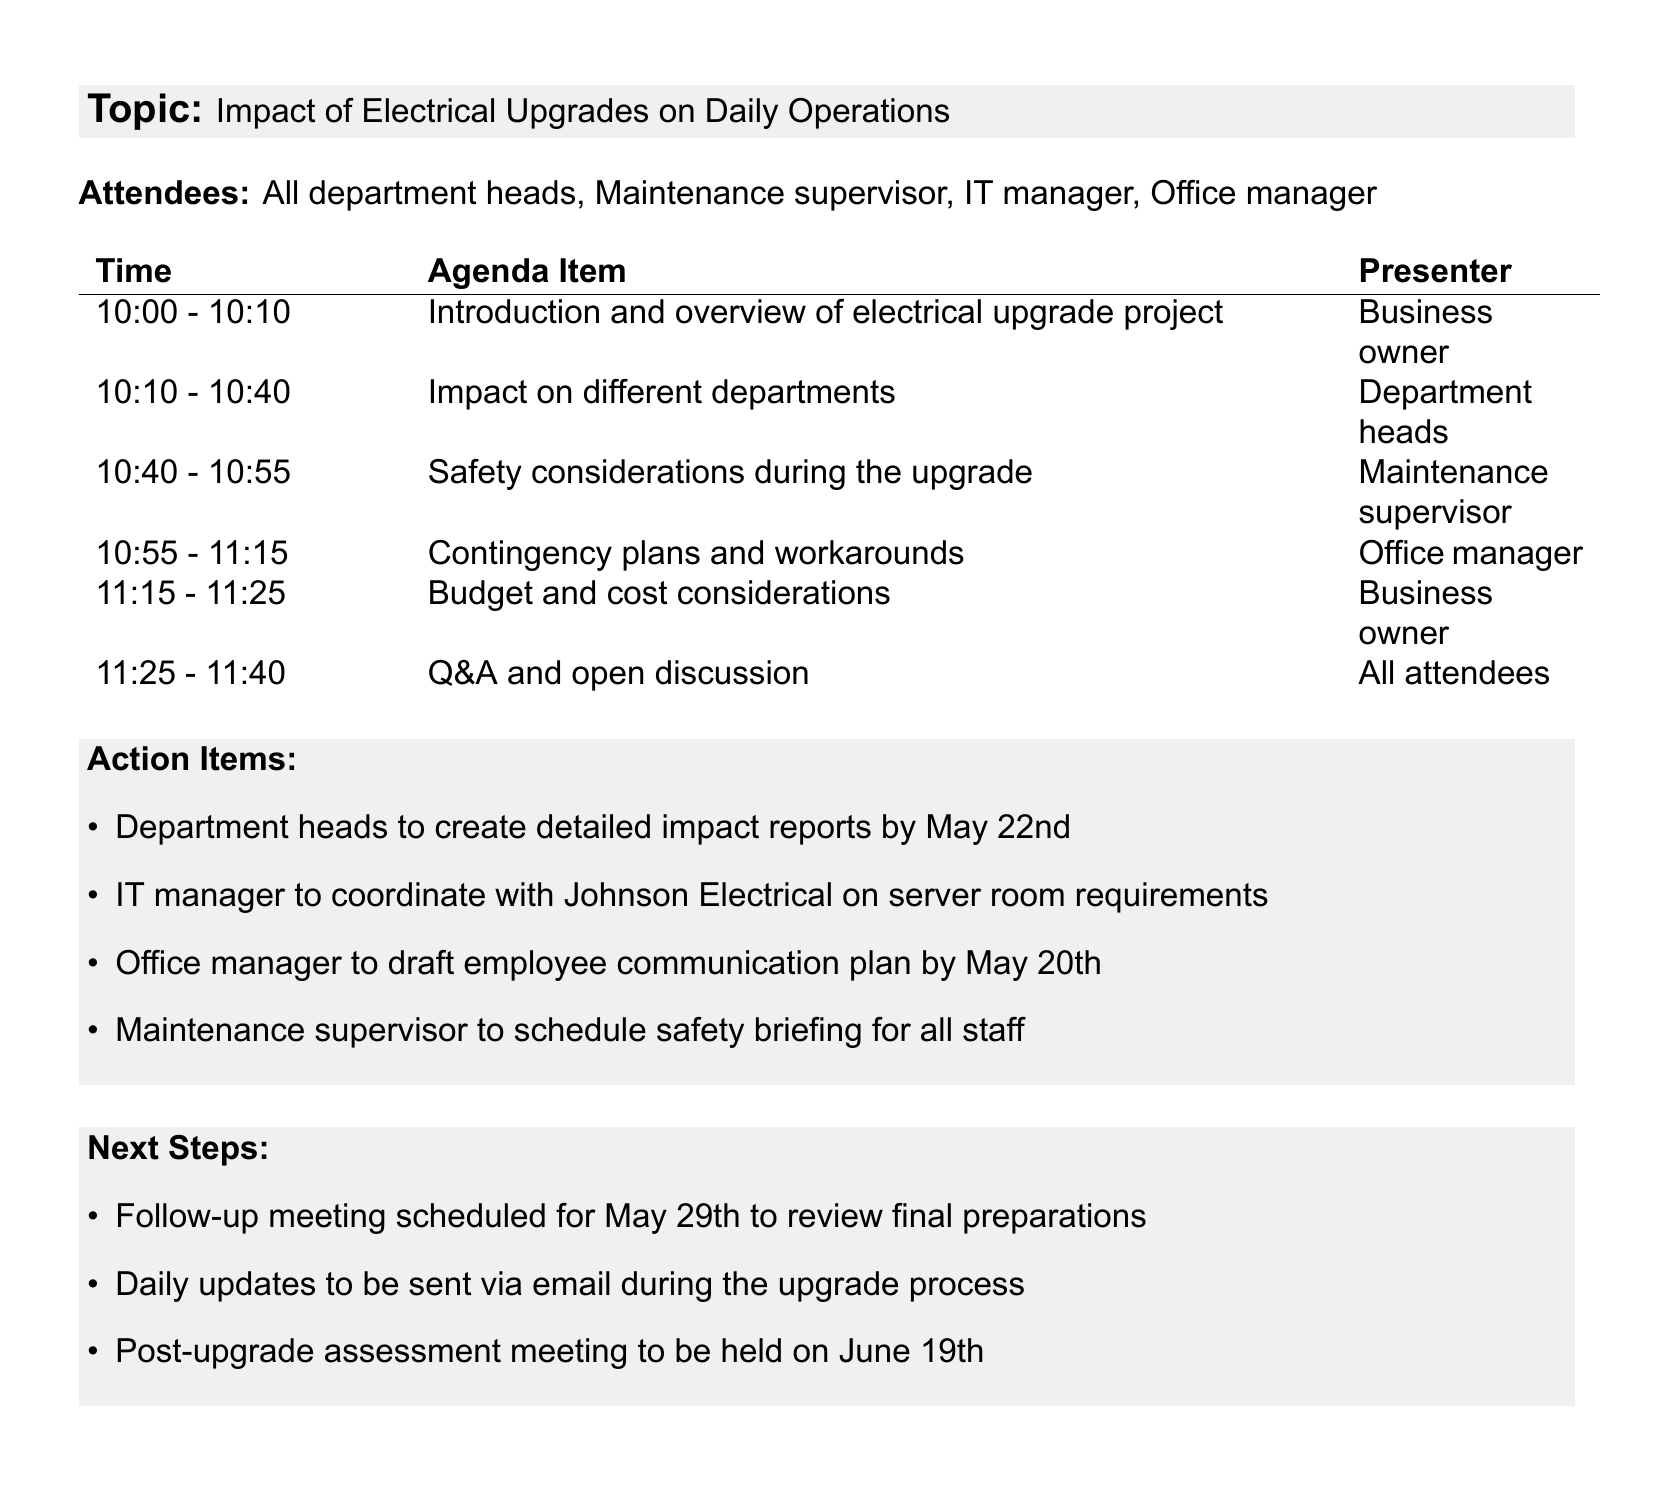what is the date of the meeting? The date of the meeting is clearly mentioned in the document at the beginning.
Answer: May 15, 2023 how long is the meeting scheduled to last? The duration of the meeting is indicated by the start and end times provided in the document.
Answer: 1 hour 30 minutes who is responsible for presenting the budget and cost considerations? The presenter for this agenda item is specified in the document.
Answer: Business owner what is the total project cost for the electrical upgrades? The total cost is listed in the budget and cost considerations section of the agenda.
Answer: $45,000 what department will discuss the safety considerations during the upgrade? This information is found in the agenda items and specifies who will be presenting.
Answer: Maintenance supervisor which service provider will handle the electrical upgrades? The name of the service provider is mentioned in the introduction section of the meeting agenda.
Answer: Johnson Electrical Solutions how many minutes are allocated for the Q&A and open discussion? The time allocated for this portion is specified alongside the agenda items.
Answer: 15 minutes when is the follow-up meeting scheduled? The follow-up meeting date is outlined in the next steps section of the agenda.
Answer: May 29th what action item is due from the IT manager? The document outlines specific tasks assigned to different individuals, including the IT manager.
Answer: Coordinate with Johnson Electrical on server room requirements 